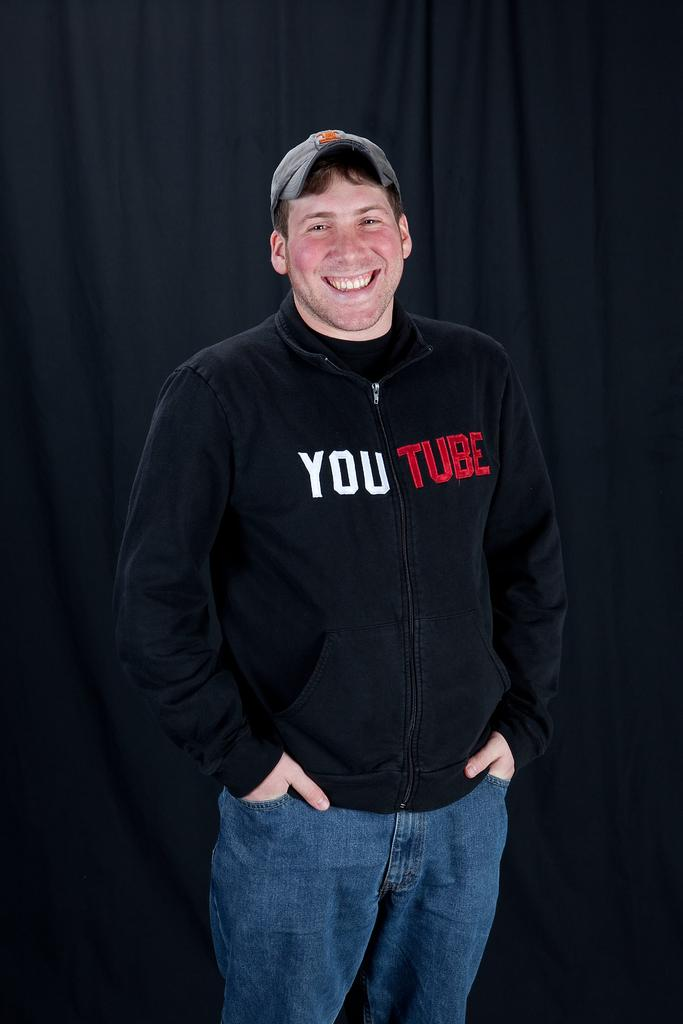Who is the main subject in the image? There is a man in the center of the image. What is the man wearing on his upper body? The man is wearing a black color hoodie. What type of headwear is the man wearing? The man is wearing a cap. What is the man's facial expression? The man is smiling. What is the man's posture in the image? The man is standing. What can be seen in the background of the image? There is a black color curtain in the background of the image. What type of stocking is the man wearing in the image? There is no mention of stockings in the image. --- Facts: 1. There is a car in the image. 2. The car is red. 3. The car has four wheels. 4. The car has a sunroof. 5. The car has a spoiler. Absurd Topics: unicorn, rainbow, umbrella Conversation: What is the main subject in the image? There is a car in the image. What is the color of the car? The car is red. How many wheels does the car have? The car has four wheels. What additional feature does the car have? The car has a sunroof. What other feature can be seen on the car? The car has a spoiler. Reasoning: Let's think step by step in order to produce the conversation. We start by identifying the main subject of the image, which is the car. Next, we describe the car's color and its wheels. Then, we mention an additional feature of the car, which is the sunroof. Finally, we describe another feature of the car, which is the spoiler. Absurd Question/Answer: Can you see a unicorn in the image? There is no unicorn present in the image. --- Facts: 1. There is a group of people in the image. 2. The people are wearing hats. 3. The people are holding hands. 4. The people are standing in a circle. 5. The people are smiling. Absurd Topics: elephant, jungle, jellyfish Conversation: How many people are in the image? There is a group of people in the image. What type of headwear are the people wearing? The people are wearing hats. What are the people doing in the image? The people are holding hands. How are the people positioned in the image? The people are standing in a circle. What is the facial expression of the people in the image? The people are smiling. Reasoning: Let's think step by step in order to produce the conversation. We start by identifying the main subject of the image, which is the group of people. Next, we describe the people's headwear and their actions. Then, we mention 